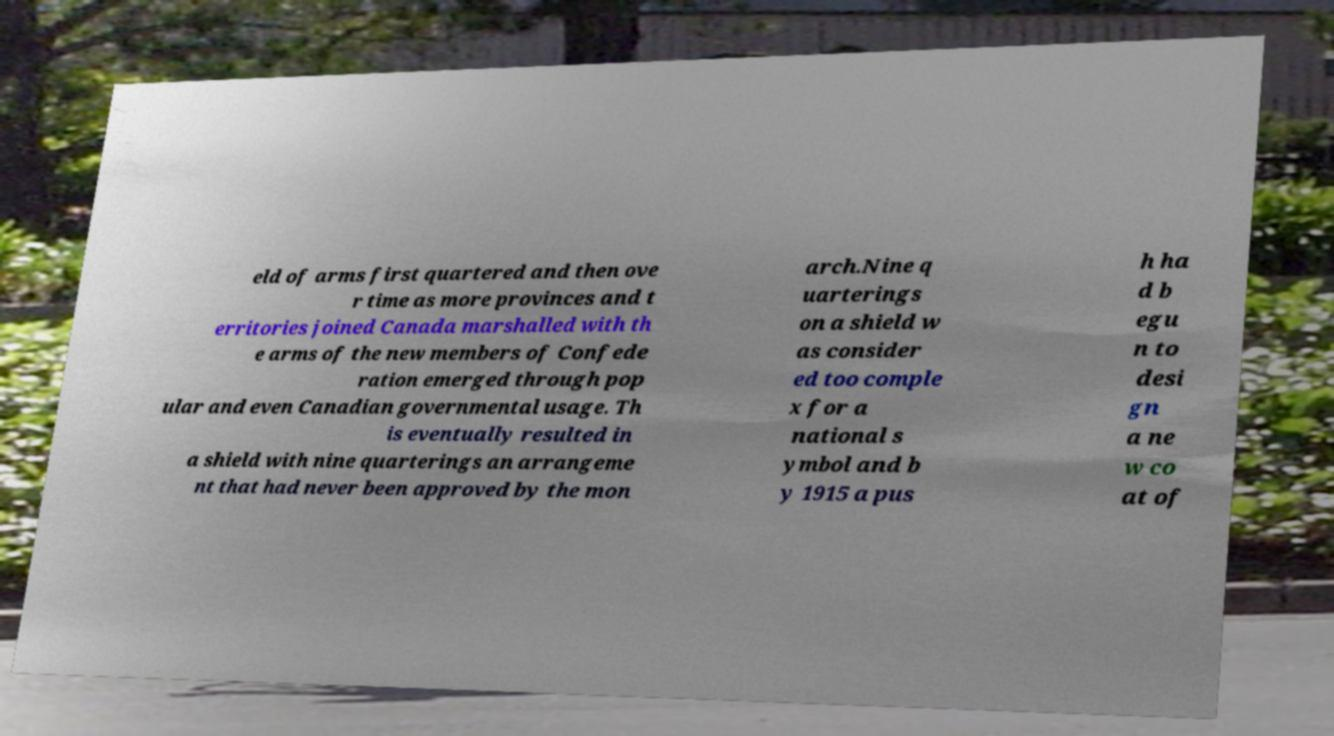Could you extract and type out the text from this image? eld of arms first quartered and then ove r time as more provinces and t erritories joined Canada marshalled with th e arms of the new members of Confede ration emerged through pop ular and even Canadian governmental usage. Th is eventually resulted in a shield with nine quarterings an arrangeme nt that had never been approved by the mon arch.Nine q uarterings on a shield w as consider ed too comple x for a national s ymbol and b y 1915 a pus h ha d b egu n to desi gn a ne w co at of 